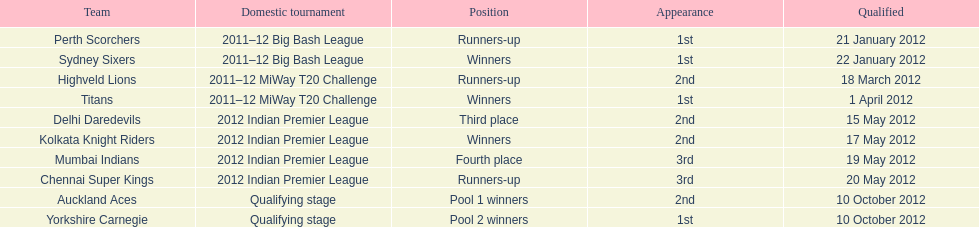Which teams were the final ones to qualify? Auckland Aces, Yorkshire Carnegie. 